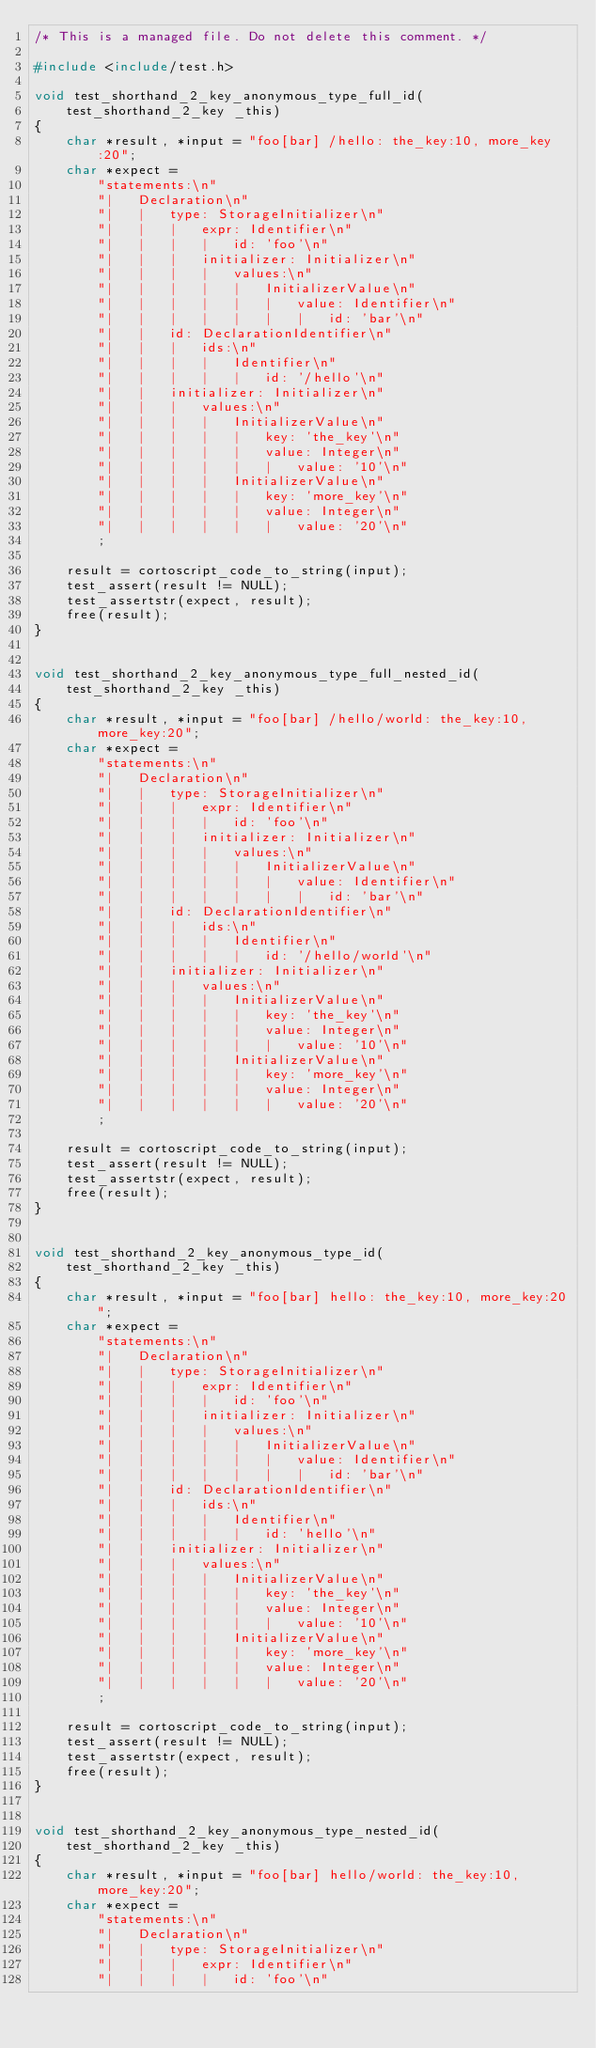<code> <loc_0><loc_0><loc_500><loc_500><_C++_>/* This is a managed file. Do not delete this comment. */

#include <include/test.h>

void test_shorthand_2_key_anonymous_type_full_id(
    test_shorthand_2_key _this)
{
    char *result, *input = "foo[bar] /hello: the_key:10, more_key:20";
    char *expect =
        "statements:\n"
        "|   Declaration\n"
        "|   |   type: StorageInitializer\n"
        "|   |   |   expr: Identifier\n"
        "|   |   |   |   id: 'foo'\n"
        "|   |   |   initializer: Initializer\n"
        "|   |   |   |   values:\n"
        "|   |   |   |   |   InitializerValue\n"
        "|   |   |   |   |   |   value: Identifier\n"
        "|   |   |   |   |   |   |   id: 'bar'\n"
        "|   |   id: DeclarationIdentifier\n"
        "|   |   |   ids:\n"
        "|   |   |   |   Identifier\n"
        "|   |   |   |   |   id: '/hello'\n"
        "|   |   initializer: Initializer\n"
        "|   |   |   values:\n"
        "|   |   |   |   InitializerValue\n"
        "|   |   |   |   |   key: 'the_key'\n"
        "|   |   |   |   |   value: Integer\n"
        "|   |   |   |   |   |   value: '10'\n"
        "|   |   |   |   InitializerValue\n"
        "|   |   |   |   |   key: 'more_key'\n"
        "|   |   |   |   |   value: Integer\n"
        "|   |   |   |   |   |   value: '20'\n"
        ;

    result = cortoscript_code_to_string(input);
    test_assert(result != NULL);
    test_assertstr(expect, result);
    free(result);
}


void test_shorthand_2_key_anonymous_type_full_nested_id(
    test_shorthand_2_key _this)
{
    char *result, *input = "foo[bar] /hello/world: the_key:10, more_key:20";
    char *expect =
        "statements:\n"
        "|   Declaration\n"
        "|   |   type: StorageInitializer\n"
        "|   |   |   expr: Identifier\n"
        "|   |   |   |   id: 'foo'\n"
        "|   |   |   initializer: Initializer\n"
        "|   |   |   |   values:\n"
        "|   |   |   |   |   InitializerValue\n"
        "|   |   |   |   |   |   value: Identifier\n"
        "|   |   |   |   |   |   |   id: 'bar'\n"
        "|   |   id: DeclarationIdentifier\n"
        "|   |   |   ids:\n"
        "|   |   |   |   Identifier\n"
        "|   |   |   |   |   id: '/hello/world'\n"
        "|   |   initializer: Initializer\n"
        "|   |   |   values:\n"
        "|   |   |   |   InitializerValue\n"
        "|   |   |   |   |   key: 'the_key'\n"
        "|   |   |   |   |   value: Integer\n"
        "|   |   |   |   |   |   value: '10'\n"
        "|   |   |   |   InitializerValue\n"
        "|   |   |   |   |   key: 'more_key'\n"
        "|   |   |   |   |   value: Integer\n"
        "|   |   |   |   |   |   value: '20'\n"
        ;

    result = cortoscript_code_to_string(input);
    test_assert(result != NULL);
    test_assertstr(expect, result);
    free(result);
}


void test_shorthand_2_key_anonymous_type_id(
    test_shorthand_2_key _this)
{
    char *result, *input = "foo[bar] hello: the_key:10, more_key:20";
    char *expect =
        "statements:\n"
        "|   Declaration\n"
        "|   |   type: StorageInitializer\n"
        "|   |   |   expr: Identifier\n"
        "|   |   |   |   id: 'foo'\n"
        "|   |   |   initializer: Initializer\n"
        "|   |   |   |   values:\n"
        "|   |   |   |   |   InitializerValue\n"
        "|   |   |   |   |   |   value: Identifier\n"
        "|   |   |   |   |   |   |   id: 'bar'\n"
        "|   |   id: DeclarationIdentifier\n"
        "|   |   |   ids:\n"
        "|   |   |   |   Identifier\n"
        "|   |   |   |   |   id: 'hello'\n"
        "|   |   initializer: Initializer\n"
        "|   |   |   values:\n"
        "|   |   |   |   InitializerValue\n"
        "|   |   |   |   |   key: 'the_key'\n"
        "|   |   |   |   |   value: Integer\n"
        "|   |   |   |   |   |   value: '10'\n"
        "|   |   |   |   InitializerValue\n"
        "|   |   |   |   |   key: 'more_key'\n"
        "|   |   |   |   |   value: Integer\n"
        "|   |   |   |   |   |   value: '20'\n"
        ;

    result = cortoscript_code_to_string(input);
    test_assert(result != NULL);
    test_assertstr(expect, result);
    free(result);
}


void test_shorthand_2_key_anonymous_type_nested_id(
    test_shorthand_2_key _this)
{
    char *result, *input = "foo[bar] hello/world: the_key:10, more_key:20";
    char *expect =
        "statements:\n"
        "|   Declaration\n"
        "|   |   type: StorageInitializer\n"
        "|   |   |   expr: Identifier\n"
        "|   |   |   |   id: 'foo'\n"</code> 